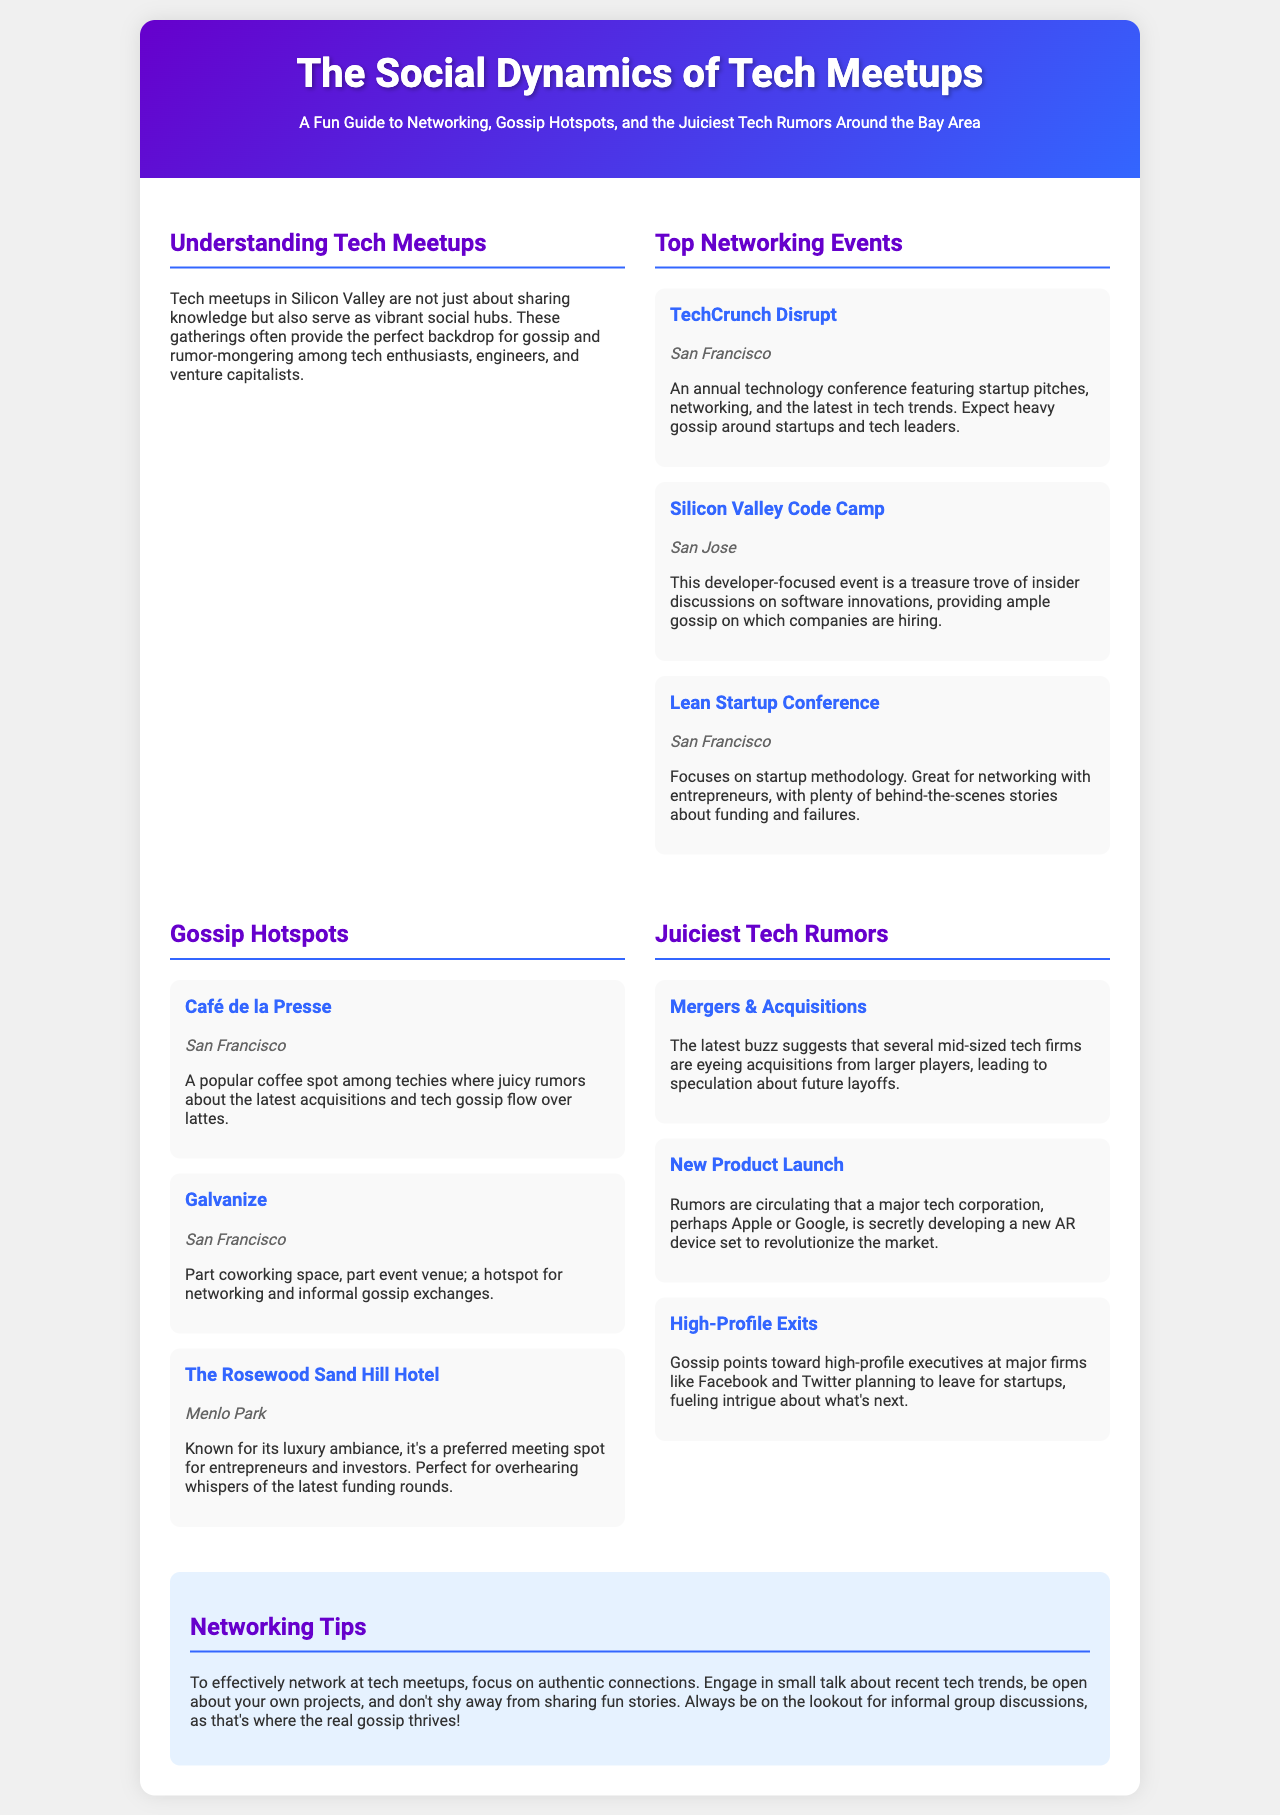what is the title of this brochure? The title is mentioned prominently at the top of the document, indicating the main theme.
Answer: The Social Dynamics of Tech Meetups where is TechCrunch Disrupt located? The location of TechCrunch Disrupt is provided in the details of the event section.
Answer: San Francisco which location is known for luxury ambiance? The document lists several gossip hotspots, indicating which one has a luxurious setting.
Answer: The Rosewood Sand Hill Hotel what type of rumors are circulating about tech corporations? The rumors section indicates specific topics related to major tech companies that are being discussed.
Answer: New Product Launch what is one of the networking tips provided? The networking tips section provides advice on how to effectively connect with others at meetups.
Answer: Engage in small talk about recent tech trends what event is developer-focused? The events listed include a specific one that caters to developers and their interests.
Answer: Silicon Valley Code Camp how many gossip hotspots are mentioned? The document lists several hotspots, allowing for easy tallying of the total.
Answer: Three what does the rumor about high-profile exits suggest? The rumors contain insights into executive movements among major firms, leading to implications about startups.
Answer: Planning to leave for startups 